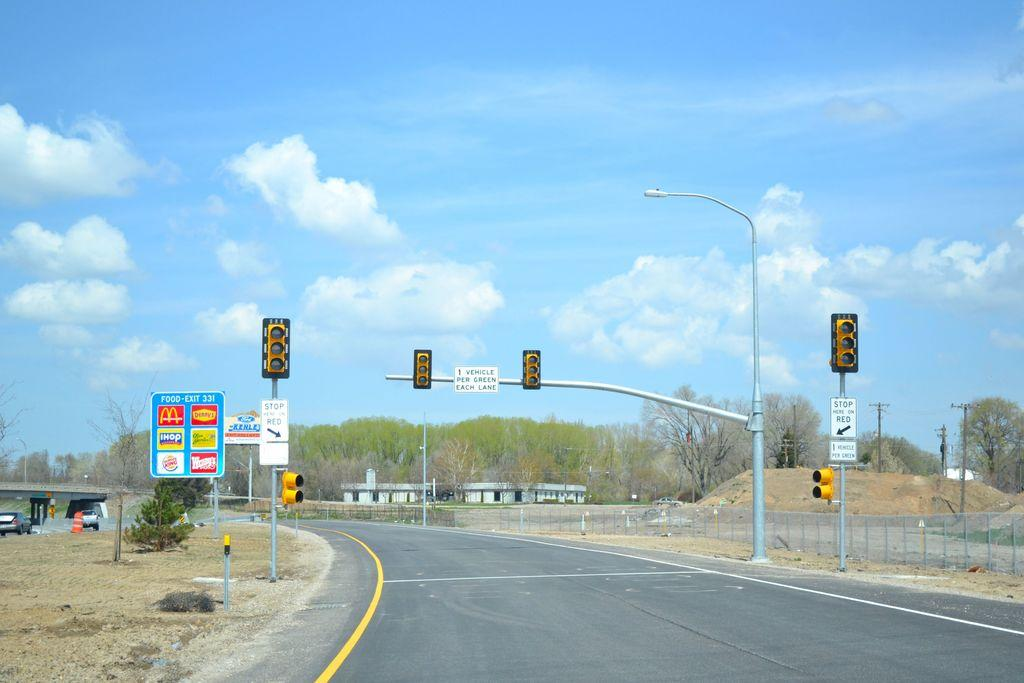<image>
Write a terse but informative summary of the picture. A road sign that shows that exit 331 has a McDonald's and  Denny's. 